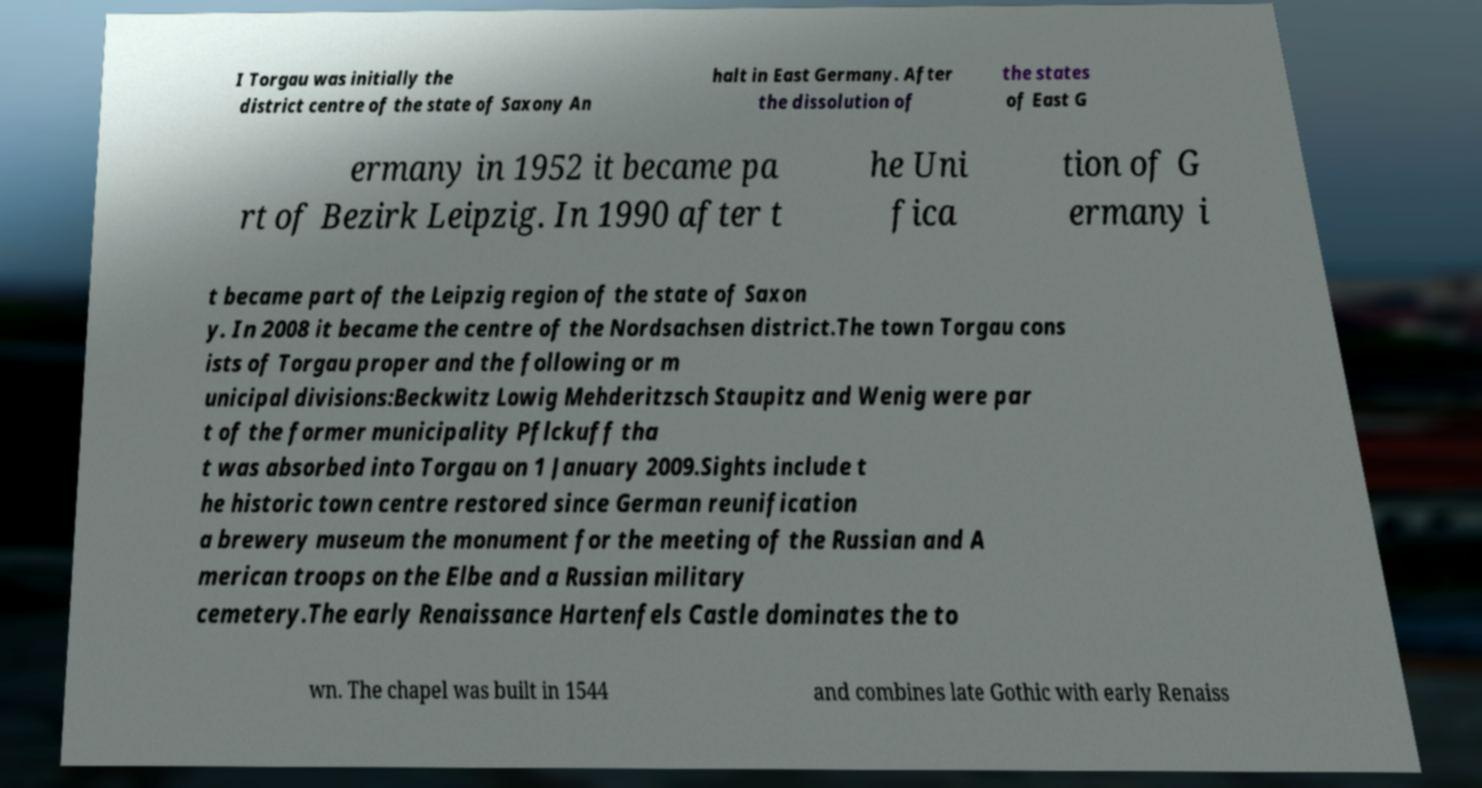Please identify and transcribe the text found in this image. I Torgau was initially the district centre of the state of Saxony An halt in East Germany. After the dissolution of the states of East G ermany in 1952 it became pa rt of Bezirk Leipzig. In 1990 after t he Uni fica tion of G ermany i t became part of the Leipzig region of the state of Saxon y. In 2008 it became the centre of the Nordsachsen district.The town Torgau cons ists of Torgau proper and the following or m unicipal divisions:Beckwitz Lowig Mehderitzsch Staupitz and Wenig were par t of the former municipality Pflckuff tha t was absorbed into Torgau on 1 January 2009.Sights include t he historic town centre restored since German reunification a brewery museum the monument for the meeting of the Russian and A merican troops on the Elbe and a Russian military cemetery.The early Renaissance Hartenfels Castle dominates the to wn. The chapel was built in 1544 and combines late Gothic with early Renaiss 